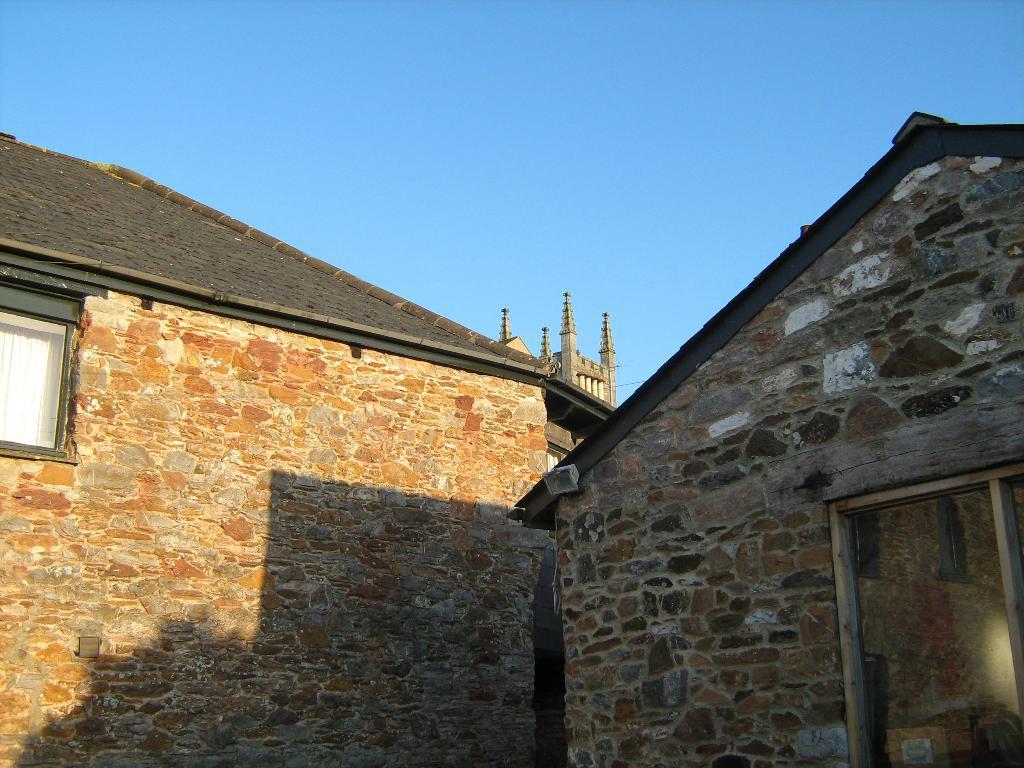Can you describe this image briefly? In this image I see the buildings and I see windows and in the background I see the sky. 